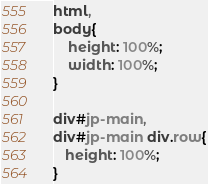<code> <loc_0><loc_0><loc_500><loc_500><_CSS_>html,
body{
    height: 100%;
    width: 100%;
}

div#jp-main,
div#jp-main div.row{
   height: 100%;
}</code> 